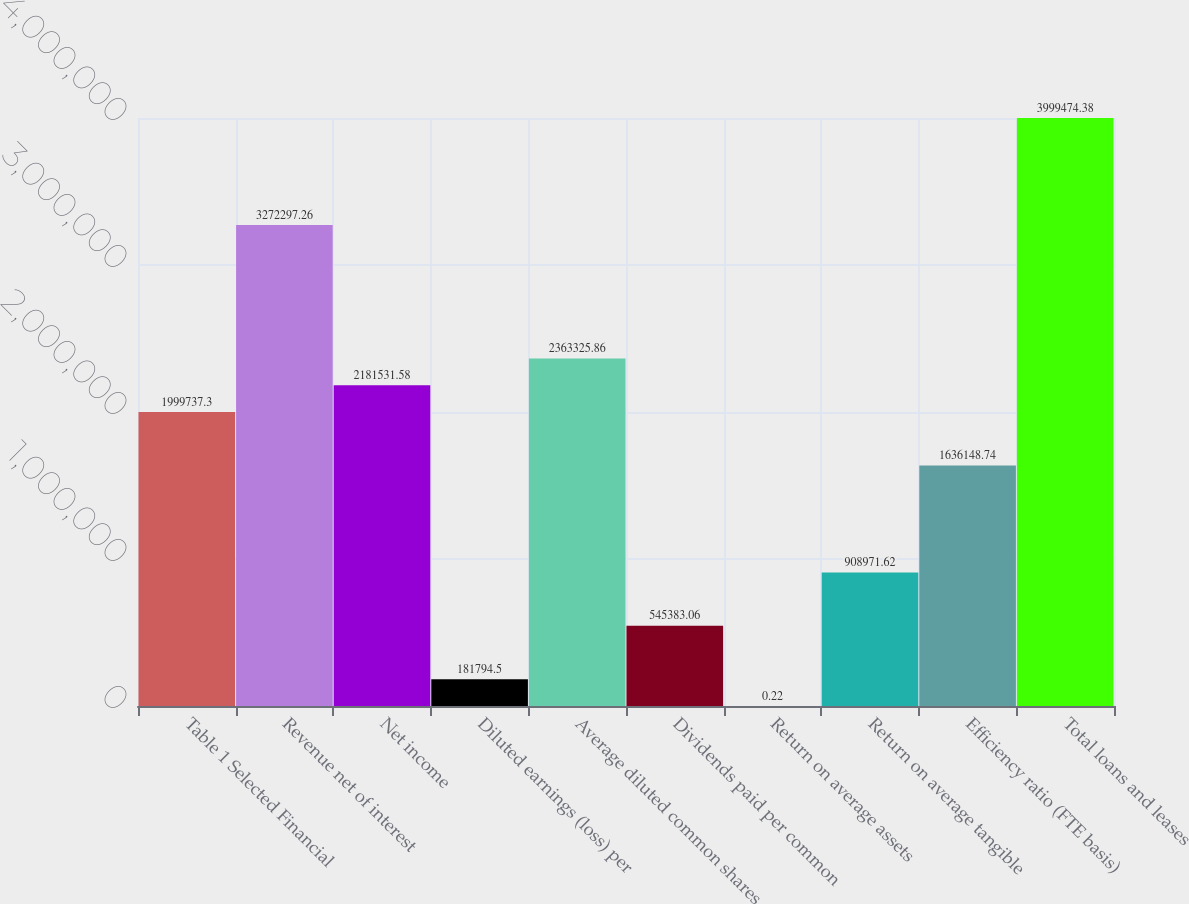<chart> <loc_0><loc_0><loc_500><loc_500><bar_chart><fcel>Table 1 Selected Financial<fcel>Revenue net of interest<fcel>Net income<fcel>Diluted earnings (loss) per<fcel>Average diluted common shares<fcel>Dividends paid per common<fcel>Return on average assets<fcel>Return on average tangible<fcel>Efficiency ratio (FTE basis)<fcel>Total loans and leases<nl><fcel>1.99974e+06<fcel>3.2723e+06<fcel>2.18153e+06<fcel>181794<fcel>2.36333e+06<fcel>545383<fcel>0.22<fcel>908972<fcel>1.63615e+06<fcel>3.99947e+06<nl></chart> 